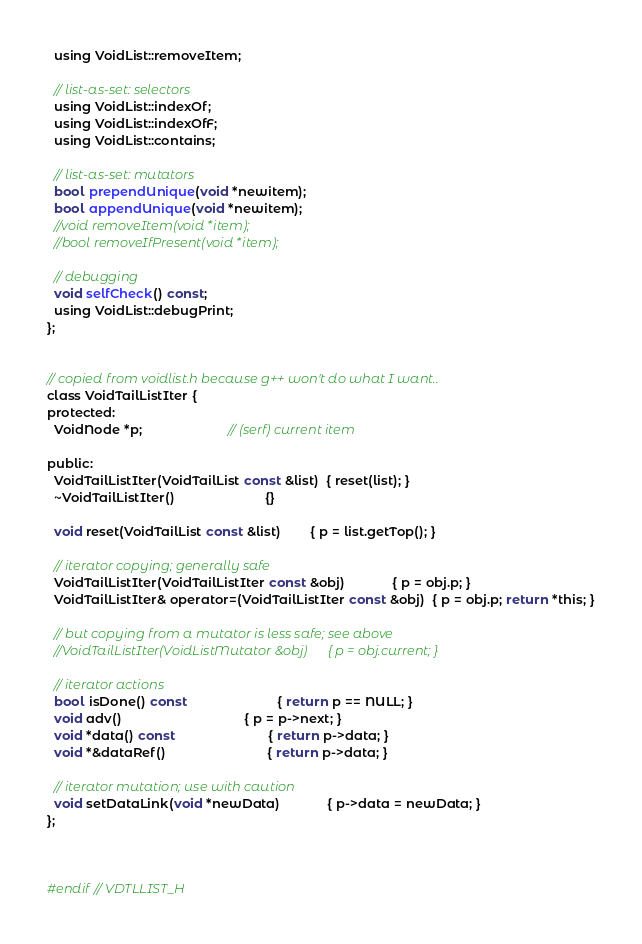Convert code to text. <code><loc_0><loc_0><loc_500><loc_500><_C_>  using VoidList::removeItem;

  // list-as-set: selectors
  using VoidList::indexOf;
  using VoidList::indexOfF;
  using VoidList::contains;

  // list-as-set: mutators
  bool prependUnique(void *newitem);
  bool appendUnique(void *newitem);
  //void removeItem(void *item);
  //bool removeIfPresent(void *item);

  // debugging
  void selfCheck() const;
  using VoidList::debugPrint;
};


// copied from voidlist.h because g++ won't do what I want..
class VoidTailListIter {
protected:
  VoidNode *p;                        // (serf) current item

public:
  VoidTailListIter(VoidTailList const &list)  { reset(list); }
  ~VoidTailListIter()                         {}

  void reset(VoidTailList const &list)        { p = list.getTop(); }

  // iterator copying; generally safe
  VoidTailListIter(VoidTailListIter const &obj)             { p = obj.p; }
  VoidTailListIter& operator=(VoidTailListIter const &obj)  { p = obj.p; return *this; }

  // but copying from a mutator is less safe; see above
  //VoidTailListIter(VoidListMutator &obj)      { p = obj.current; }

  // iterator actions
  bool isDone() const                         { return p == NULL; }
  void adv()                                  { p = p->next; }
  void *data() const                          { return p->data; }
  void *&dataRef()                            { return p->data; }

  // iterator mutation; use with caution
  void setDataLink(void *newData)             { p->data = newData; }
};



#endif // VDTLLIST_H
</code> 